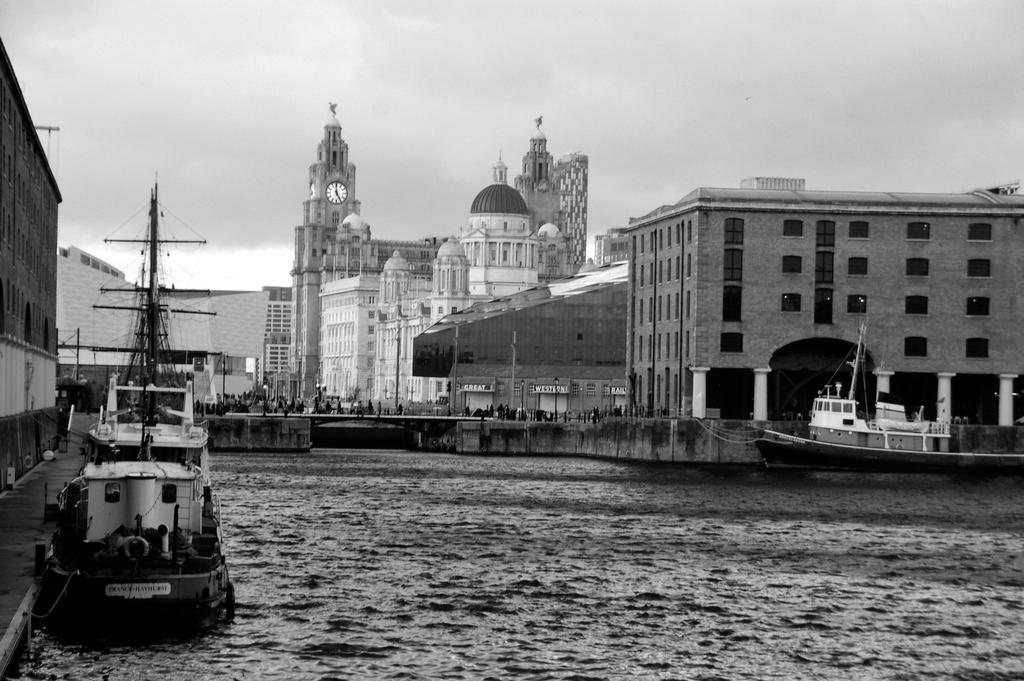Can you describe this image briefly? In this image in the front there is water and on the left side there is a ship on the water. In the background there is a ship on the water and there are buildings, persons and there is a clock tower and the sky is cloudy. On the left side there is a building. 